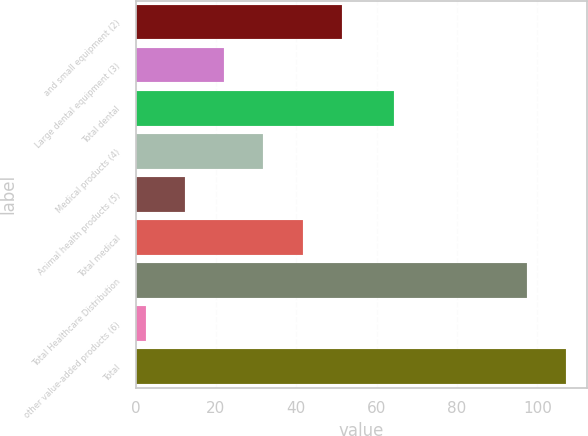<chart> <loc_0><loc_0><loc_500><loc_500><bar_chart><fcel>and small equipment (2)<fcel>Large dental equipment (3)<fcel>Total dental<fcel>Medical products (4)<fcel>Animal health products (5)<fcel>Total medical<fcel>Total Healthcare Distribution<fcel>other value-added products (6)<fcel>Total<nl><fcel>51.3<fcel>22.08<fcel>64.3<fcel>31.82<fcel>12.34<fcel>41.56<fcel>97.4<fcel>2.6<fcel>107.14<nl></chart> 